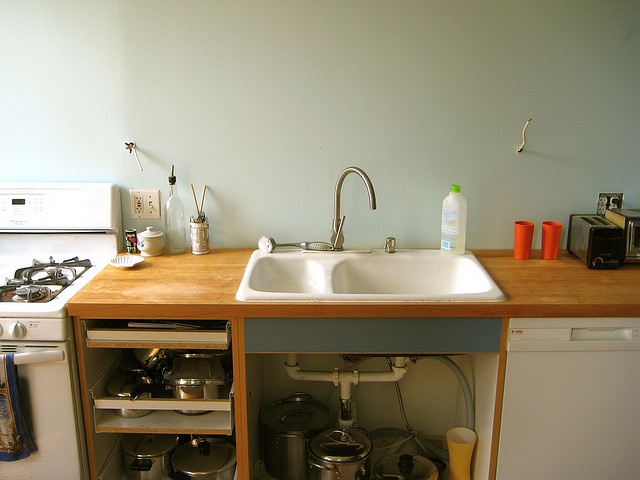Describe the objects in this image and their specific colors. I can see oven in beige, white, tan, and black tones, sink in beige, ivory, and tan tones, toaster in beige, black, darkgreen, gray, and maroon tones, bowl in beige, black, olive, and gray tones, and bottle in beige, lightgray, darkgray, and tan tones in this image. 